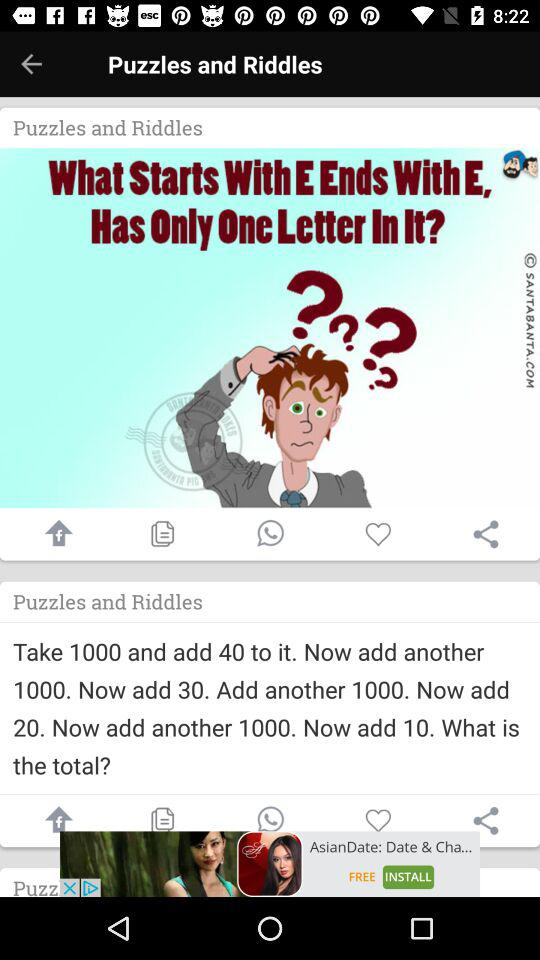What is the application name?
When the provided information is insufficient, respond with <no answer>. <no answer> 